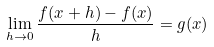<formula> <loc_0><loc_0><loc_500><loc_500>\lim _ { h \to 0 } \frac { f ( x + h ) - f ( x ) } { h } = g ( x )</formula> 